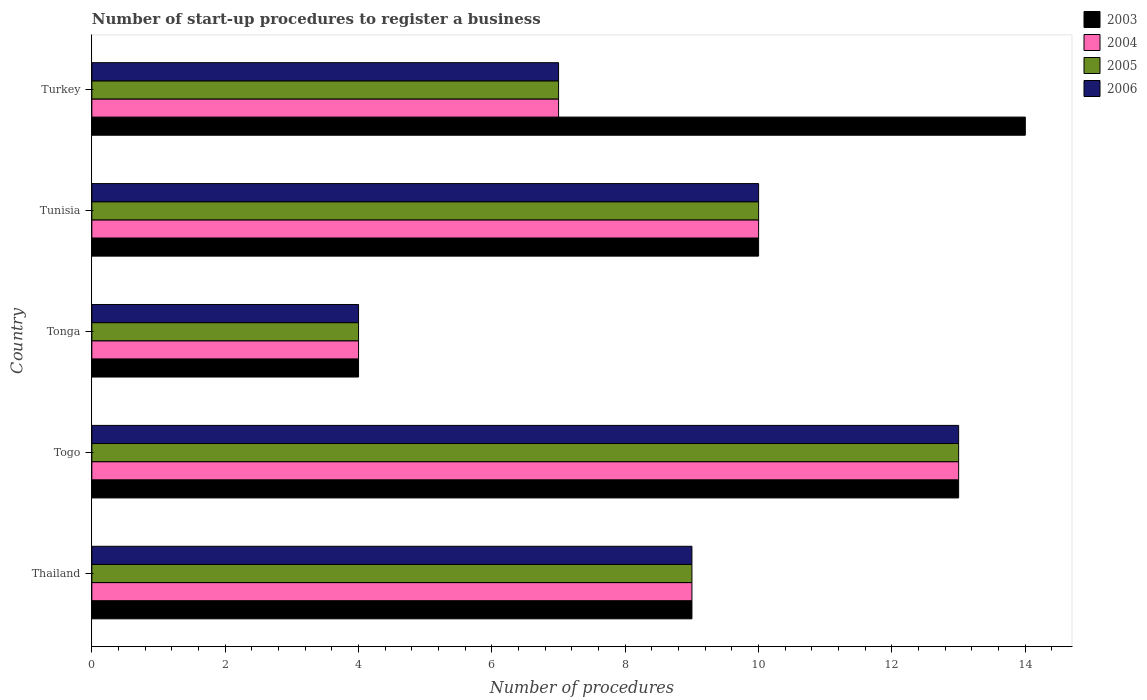How many different coloured bars are there?
Make the answer very short. 4. Are the number of bars per tick equal to the number of legend labels?
Keep it short and to the point. Yes. What is the label of the 5th group of bars from the top?
Provide a succinct answer. Thailand. In how many cases, is the number of bars for a given country not equal to the number of legend labels?
Provide a short and direct response. 0. Across all countries, what is the maximum number of procedures required to register a business in 2005?
Provide a succinct answer. 13. Across all countries, what is the minimum number of procedures required to register a business in 2005?
Offer a terse response. 4. In which country was the number of procedures required to register a business in 2005 maximum?
Your answer should be compact. Togo. In which country was the number of procedures required to register a business in 2006 minimum?
Your response must be concise. Tonga. What is the difference between the number of procedures required to register a business in 2004 in Tunisia and the number of procedures required to register a business in 2003 in Thailand?
Give a very brief answer. 1. In how many countries, is the number of procedures required to register a business in 2006 greater than 7.6 ?
Offer a terse response. 3. What is the ratio of the number of procedures required to register a business in 2005 in Tonga to that in Turkey?
Your answer should be very brief. 0.57. What is the difference between the highest and the second highest number of procedures required to register a business in 2004?
Provide a succinct answer. 3. What is the difference between the highest and the lowest number of procedures required to register a business in 2005?
Make the answer very short. 9. In how many countries, is the number of procedures required to register a business in 2005 greater than the average number of procedures required to register a business in 2005 taken over all countries?
Provide a short and direct response. 3. Is the sum of the number of procedures required to register a business in 2006 in Thailand and Turkey greater than the maximum number of procedures required to register a business in 2004 across all countries?
Your response must be concise. Yes. What does the 1st bar from the top in Tonga represents?
Keep it short and to the point. 2006. Is it the case that in every country, the sum of the number of procedures required to register a business in 2004 and number of procedures required to register a business in 2005 is greater than the number of procedures required to register a business in 2006?
Make the answer very short. Yes. How many bars are there?
Your response must be concise. 20. Are the values on the major ticks of X-axis written in scientific E-notation?
Offer a very short reply. No. Where does the legend appear in the graph?
Offer a terse response. Top right. How many legend labels are there?
Your answer should be very brief. 4. How are the legend labels stacked?
Offer a terse response. Vertical. What is the title of the graph?
Offer a terse response. Number of start-up procedures to register a business. Does "1989" appear as one of the legend labels in the graph?
Give a very brief answer. No. What is the label or title of the X-axis?
Give a very brief answer. Number of procedures. What is the label or title of the Y-axis?
Your response must be concise. Country. What is the Number of procedures in 2003 in Thailand?
Provide a succinct answer. 9. What is the Number of procedures in 2005 in Thailand?
Your answer should be compact. 9. What is the Number of procedures of 2006 in Thailand?
Your answer should be very brief. 9. What is the Number of procedures of 2005 in Togo?
Your answer should be compact. 13. What is the Number of procedures in 2006 in Togo?
Provide a short and direct response. 13. What is the Number of procedures of 2003 in Tonga?
Provide a short and direct response. 4. What is the Number of procedures of 2003 in Tunisia?
Your response must be concise. 10. What is the Number of procedures of 2003 in Turkey?
Keep it short and to the point. 14. What is the Number of procedures in 2005 in Turkey?
Ensure brevity in your answer.  7. What is the Number of procedures in 2006 in Turkey?
Your answer should be very brief. 7. Across all countries, what is the maximum Number of procedures in 2003?
Provide a succinct answer. 14. Across all countries, what is the maximum Number of procedures in 2004?
Ensure brevity in your answer.  13. Across all countries, what is the maximum Number of procedures of 2006?
Make the answer very short. 13. Across all countries, what is the minimum Number of procedures in 2003?
Ensure brevity in your answer.  4. Across all countries, what is the minimum Number of procedures in 2004?
Give a very brief answer. 4. What is the total Number of procedures in 2006 in the graph?
Provide a succinct answer. 43. What is the difference between the Number of procedures in 2005 in Thailand and that in Togo?
Keep it short and to the point. -4. What is the difference between the Number of procedures in 2003 in Thailand and that in Tonga?
Keep it short and to the point. 5. What is the difference between the Number of procedures of 2005 in Thailand and that in Tonga?
Offer a terse response. 5. What is the difference between the Number of procedures in 2003 in Thailand and that in Tunisia?
Provide a succinct answer. -1. What is the difference between the Number of procedures of 2006 in Thailand and that in Tunisia?
Provide a short and direct response. -1. What is the difference between the Number of procedures of 2003 in Thailand and that in Turkey?
Make the answer very short. -5. What is the difference between the Number of procedures in 2005 in Thailand and that in Turkey?
Offer a terse response. 2. What is the difference between the Number of procedures of 2006 in Thailand and that in Turkey?
Provide a short and direct response. 2. What is the difference between the Number of procedures in 2005 in Togo and that in Tonga?
Make the answer very short. 9. What is the difference between the Number of procedures of 2006 in Togo and that in Tonga?
Provide a short and direct response. 9. What is the difference between the Number of procedures of 2004 in Togo and that in Turkey?
Ensure brevity in your answer.  6. What is the difference between the Number of procedures in 2005 in Togo and that in Turkey?
Keep it short and to the point. 6. What is the difference between the Number of procedures of 2006 in Togo and that in Turkey?
Offer a very short reply. 6. What is the difference between the Number of procedures of 2003 in Tonga and that in Tunisia?
Offer a very short reply. -6. What is the difference between the Number of procedures of 2004 in Tonga and that in Tunisia?
Make the answer very short. -6. What is the difference between the Number of procedures in 2005 in Tonga and that in Tunisia?
Offer a very short reply. -6. What is the difference between the Number of procedures of 2006 in Tonga and that in Tunisia?
Offer a very short reply. -6. What is the difference between the Number of procedures in 2003 in Tonga and that in Turkey?
Your answer should be compact. -10. What is the difference between the Number of procedures of 2004 in Tonga and that in Turkey?
Provide a succinct answer. -3. What is the difference between the Number of procedures in 2006 in Tonga and that in Turkey?
Ensure brevity in your answer.  -3. What is the difference between the Number of procedures of 2003 in Tunisia and that in Turkey?
Ensure brevity in your answer.  -4. What is the difference between the Number of procedures of 2003 in Thailand and the Number of procedures of 2004 in Togo?
Your answer should be very brief. -4. What is the difference between the Number of procedures of 2004 in Thailand and the Number of procedures of 2005 in Togo?
Make the answer very short. -4. What is the difference between the Number of procedures in 2004 in Thailand and the Number of procedures in 2006 in Togo?
Ensure brevity in your answer.  -4. What is the difference between the Number of procedures of 2005 in Thailand and the Number of procedures of 2006 in Togo?
Your answer should be very brief. -4. What is the difference between the Number of procedures of 2003 in Thailand and the Number of procedures of 2004 in Tonga?
Your response must be concise. 5. What is the difference between the Number of procedures in 2004 in Thailand and the Number of procedures in 2005 in Tonga?
Provide a short and direct response. 5. What is the difference between the Number of procedures of 2004 in Thailand and the Number of procedures of 2006 in Tonga?
Your answer should be very brief. 5. What is the difference between the Number of procedures of 2003 in Thailand and the Number of procedures of 2006 in Tunisia?
Keep it short and to the point. -1. What is the difference between the Number of procedures in 2004 in Thailand and the Number of procedures in 2006 in Tunisia?
Offer a terse response. -1. What is the difference between the Number of procedures of 2005 in Thailand and the Number of procedures of 2006 in Tunisia?
Keep it short and to the point. -1. What is the difference between the Number of procedures of 2003 in Thailand and the Number of procedures of 2005 in Turkey?
Give a very brief answer. 2. What is the difference between the Number of procedures of 2003 in Thailand and the Number of procedures of 2006 in Turkey?
Your answer should be very brief. 2. What is the difference between the Number of procedures in 2003 in Togo and the Number of procedures in 2004 in Tonga?
Offer a terse response. 9. What is the difference between the Number of procedures in 2003 in Togo and the Number of procedures in 2005 in Tonga?
Ensure brevity in your answer.  9. What is the difference between the Number of procedures in 2004 in Togo and the Number of procedures in 2005 in Tonga?
Your answer should be very brief. 9. What is the difference between the Number of procedures in 2005 in Togo and the Number of procedures in 2006 in Tonga?
Keep it short and to the point. 9. What is the difference between the Number of procedures in 2003 in Togo and the Number of procedures in 2006 in Tunisia?
Provide a succinct answer. 3. What is the difference between the Number of procedures in 2005 in Togo and the Number of procedures in 2006 in Tunisia?
Provide a succinct answer. 3. What is the difference between the Number of procedures in 2004 in Togo and the Number of procedures in 2006 in Turkey?
Provide a succinct answer. 6. What is the difference between the Number of procedures in 2005 in Togo and the Number of procedures in 2006 in Turkey?
Ensure brevity in your answer.  6. What is the difference between the Number of procedures of 2003 in Tonga and the Number of procedures of 2004 in Tunisia?
Keep it short and to the point. -6. What is the difference between the Number of procedures in 2003 in Tonga and the Number of procedures in 2006 in Tunisia?
Offer a terse response. -6. What is the difference between the Number of procedures of 2004 in Tonga and the Number of procedures of 2005 in Tunisia?
Provide a short and direct response. -6. What is the difference between the Number of procedures of 2005 in Tonga and the Number of procedures of 2006 in Tunisia?
Make the answer very short. -6. What is the difference between the Number of procedures of 2003 in Tonga and the Number of procedures of 2005 in Turkey?
Keep it short and to the point. -3. What is the difference between the Number of procedures of 2003 in Tunisia and the Number of procedures of 2005 in Turkey?
Provide a short and direct response. 3. What is the difference between the Number of procedures of 2003 in Tunisia and the Number of procedures of 2006 in Turkey?
Provide a succinct answer. 3. What is the difference between the Number of procedures of 2004 in Tunisia and the Number of procedures of 2005 in Turkey?
Your answer should be very brief. 3. What is the difference between the Number of procedures of 2004 in Tunisia and the Number of procedures of 2006 in Turkey?
Make the answer very short. 3. What is the difference between the Number of procedures in 2005 in Tunisia and the Number of procedures in 2006 in Turkey?
Offer a very short reply. 3. What is the average Number of procedures in 2004 per country?
Your answer should be very brief. 8.6. What is the average Number of procedures of 2005 per country?
Offer a terse response. 8.6. What is the difference between the Number of procedures of 2003 and Number of procedures of 2005 in Thailand?
Your response must be concise. 0. What is the difference between the Number of procedures of 2003 and Number of procedures of 2006 in Thailand?
Give a very brief answer. 0. What is the difference between the Number of procedures of 2004 and Number of procedures of 2005 in Thailand?
Offer a very short reply. 0. What is the difference between the Number of procedures in 2003 and Number of procedures in 2004 in Togo?
Offer a very short reply. 0. What is the difference between the Number of procedures of 2003 and Number of procedures of 2005 in Togo?
Make the answer very short. 0. What is the difference between the Number of procedures in 2003 and Number of procedures in 2005 in Tonga?
Your answer should be compact. 0. What is the difference between the Number of procedures in 2004 and Number of procedures in 2006 in Tonga?
Give a very brief answer. 0. What is the difference between the Number of procedures of 2005 and Number of procedures of 2006 in Tonga?
Your answer should be very brief. 0. What is the difference between the Number of procedures in 2003 and Number of procedures in 2005 in Tunisia?
Give a very brief answer. 0. What is the difference between the Number of procedures of 2003 and Number of procedures of 2006 in Tunisia?
Provide a succinct answer. 0. What is the difference between the Number of procedures in 2005 and Number of procedures in 2006 in Tunisia?
Provide a succinct answer. 0. What is the difference between the Number of procedures of 2003 and Number of procedures of 2005 in Turkey?
Keep it short and to the point. 7. What is the difference between the Number of procedures of 2005 and Number of procedures of 2006 in Turkey?
Ensure brevity in your answer.  0. What is the ratio of the Number of procedures in 2003 in Thailand to that in Togo?
Your response must be concise. 0.69. What is the ratio of the Number of procedures of 2004 in Thailand to that in Togo?
Keep it short and to the point. 0.69. What is the ratio of the Number of procedures of 2005 in Thailand to that in Togo?
Your response must be concise. 0.69. What is the ratio of the Number of procedures of 2006 in Thailand to that in Togo?
Provide a succinct answer. 0.69. What is the ratio of the Number of procedures of 2003 in Thailand to that in Tonga?
Give a very brief answer. 2.25. What is the ratio of the Number of procedures of 2004 in Thailand to that in Tonga?
Provide a succinct answer. 2.25. What is the ratio of the Number of procedures in 2005 in Thailand to that in Tonga?
Provide a short and direct response. 2.25. What is the ratio of the Number of procedures in 2006 in Thailand to that in Tonga?
Your answer should be compact. 2.25. What is the ratio of the Number of procedures in 2004 in Thailand to that in Tunisia?
Your answer should be very brief. 0.9. What is the ratio of the Number of procedures in 2005 in Thailand to that in Tunisia?
Give a very brief answer. 0.9. What is the ratio of the Number of procedures of 2006 in Thailand to that in Tunisia?
Provide a succinct answer. 0.9. What is the ratio of the Number of procedures of 2003 in Thailand to that in Turkey?
Your answer should be very brief. 0.64. What is the ratio of the Number of procedures in 2004 in Thailand to that in Turkey?
Keep it short and to the point. 1.29. What is the ratio of the Number of procedures in 2006 in Thailand to that in Turkey?
Ensure brevity in your answer.  1.29. What is the ratio of the Number of procedures of 2003 in Togo to that in Tonga?
Offer a very short reply. 3.25. What is the ratio of the Number of procedures of 2006 in Togo to that in Tonga?
Provide a short and direct response. 3.25. What is the ratio of the Number of procedures of 2003 in Togo to that in Tunisia?
Your answer should be very brief. 1.3. What is the ratio of the Number of procedures in 2006 in Togo to that in Tunisia?
Offer a terse response. 1.3. What is the ratio of the Number of procedures of 2003 in Togo to that in Turkey?
Give a very brief answer. 0.93. What is the ratio of the Number of procedures in 2004 in Togo to that in Turkey?
Give a very brief answer. 1.86. What is the ratio of the Number of procedures in 2005 in Togo to that in Turkey?
Your answer should be compact. 1.86. What is the ratio of the Number of procedures of 2006 in Togo to that in Turkey?
Provide a short and direct response. 1.86. What is the ratio of the Number of procedures in 2006 in Tonga to that in Tunisia?
Keep it short and to the point. 0.4. What is the ratio of the Number of procedures in 2003 in Tonga to that in Turkey?
Offer a very short reply. 0.29. What is the ratio of the Number of procedures of 2006 in Tonga to that in Turkey?
Ensure brevity in your answer.  0.57. What is the ratio of the Number of procedures in 2003 in Tunisia to that in Turkey?
Give a very brief answer. 0.71. What is the ratio of the Number of procedures of 2004 in Tunisia to that in Turkey?
Provide a succinct answer. 1.43. What is the ratio of the Number of procedures in 2005 in Tunisia to that in Turkey?
Make the answer very short. 1.43. What is the ratio of the Number of procedures of 2006 in Tunisia to that in Turkey?
Offer a very short reply. 1.43. What is the difference between the highest and the second highest Number of procedures of 2003?
Provide a short and direct response. 1. What is the difference between the highest and the lowest Number of procedures in 2003?
Your answer should be compact. 10. 